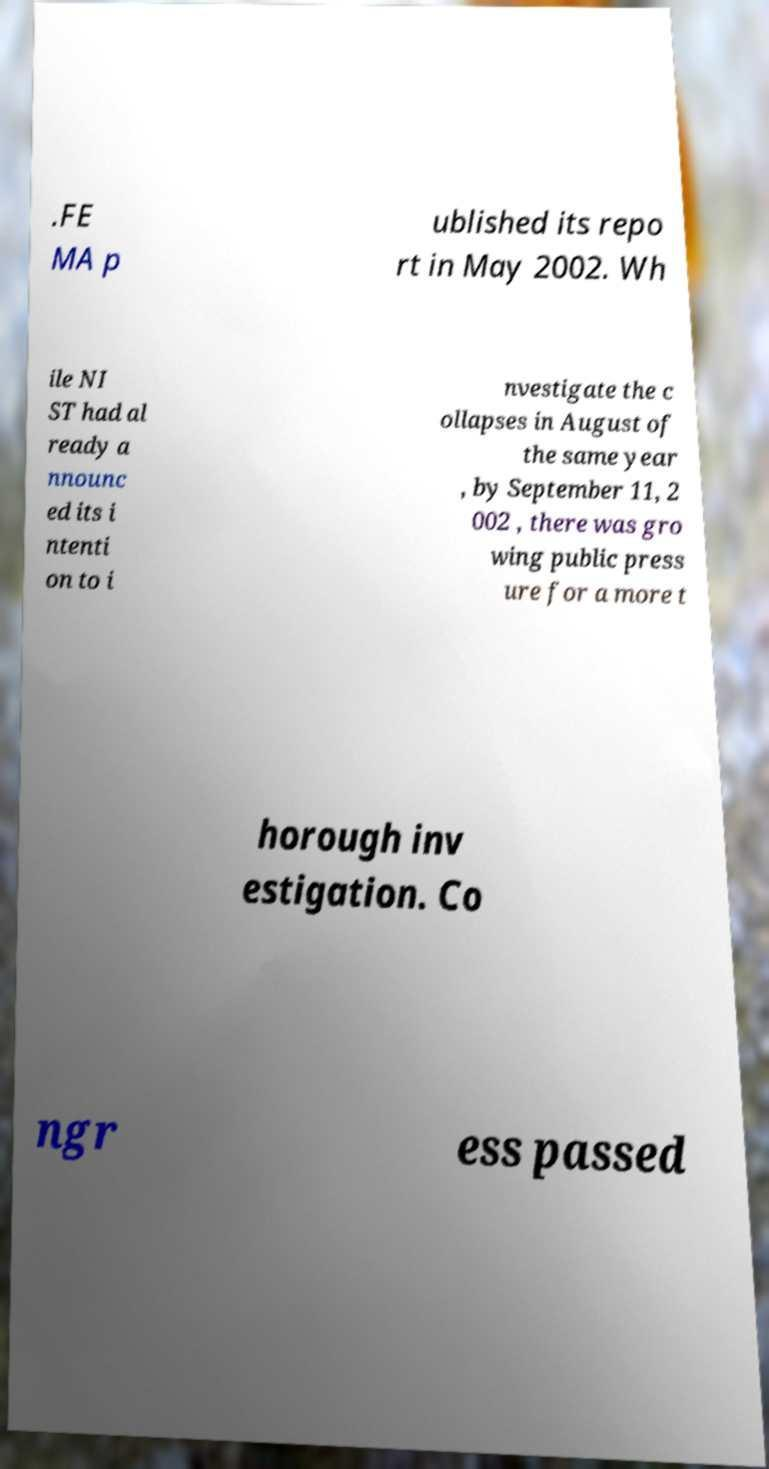Can you accurately transcribe the text from the provided image for me? .FE MA p ublished its repo rt in May 2002. Wh ile NI ST had al ready a nnounc ed its i ntenti on to i nvestigate the c ollapses in August of the same year , by September 11, 2 002 , there was gro wing public press ure for a more t horough inv estigation. Co ngr ess passed 